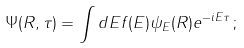<formula> <loc_0><loc_0><loc_500><loc_500>\Psi ( R , \tau ) = \int d E f ( E ) \psi _ { E } ( R ) e ^ { - i E \tau } \, ;</formula> 